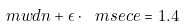Convert formula to latex. <formula><loc_0><loc_0><loc_500><loc_500>\ m w d n + \epsilon \cdot \ m s e c e = 1 . 4</formula> 